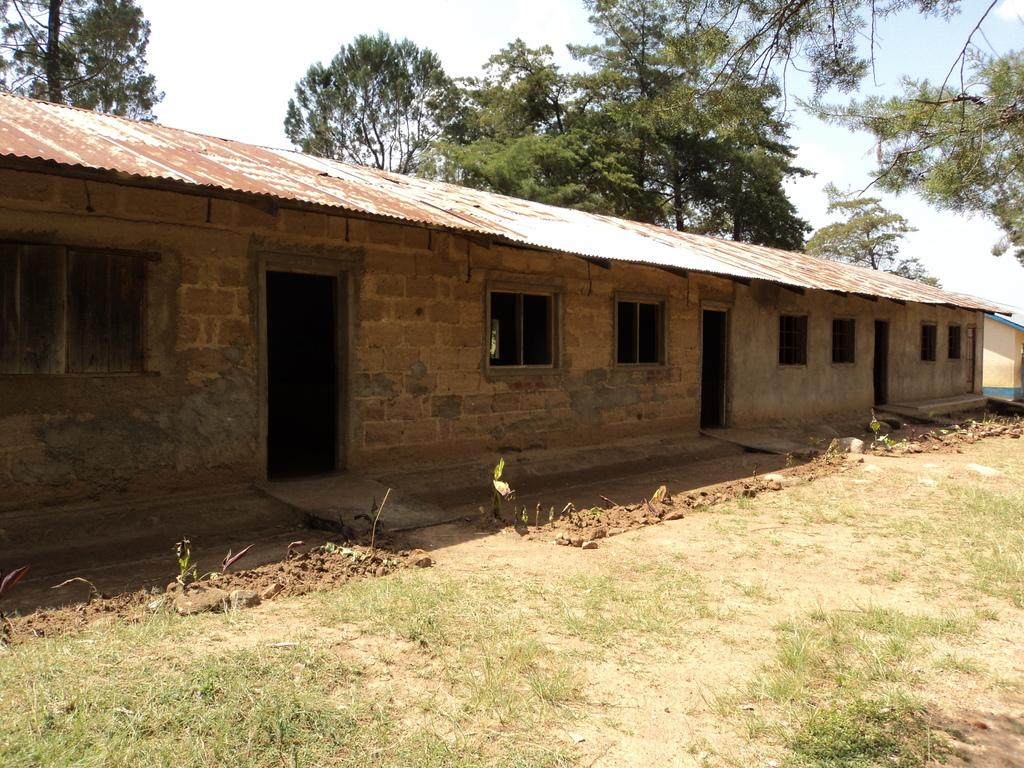What is the main subject of the image? There is a building at the center of the image. What is located in front of the building? There are plants and grass in front of the building. What can be seen in the background of the image? There are trees and the sky visible in the background of the image. What type of dog can be seen playing with a rod in the image? There is no dog or rod present in the image; it features a building with plants, grass, trees, and the sky in the background. 